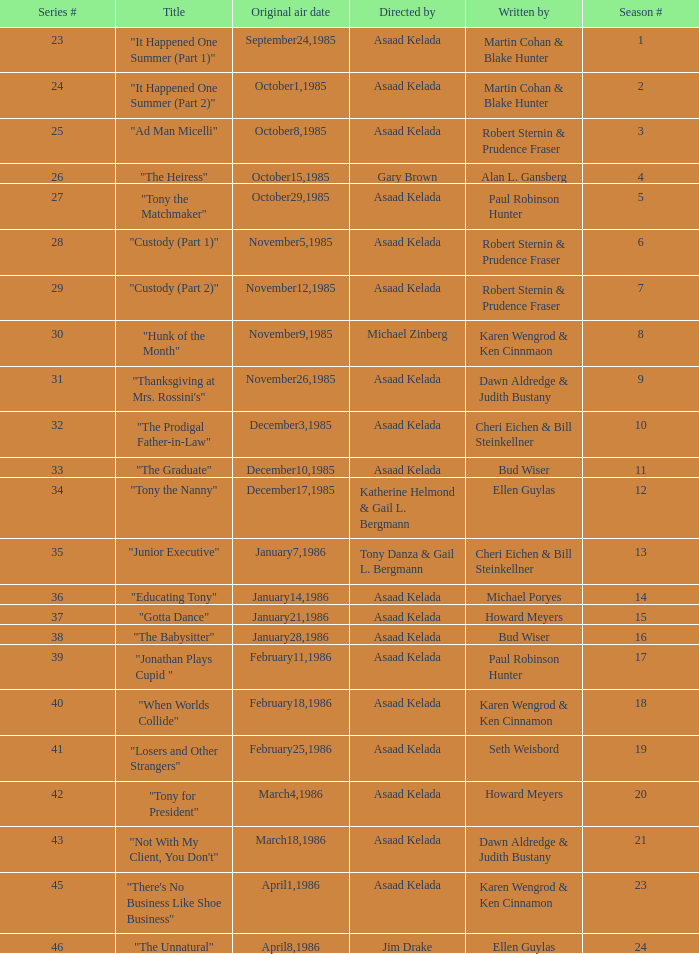What is the date of the episode written by Michael Poryes? January14,1986. 